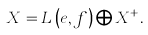<formula> <loc_0><loc_0><loc_500><loc_500>X = L \left ( e , f \right ) \bigoplus X ^ { + } .</formula> 